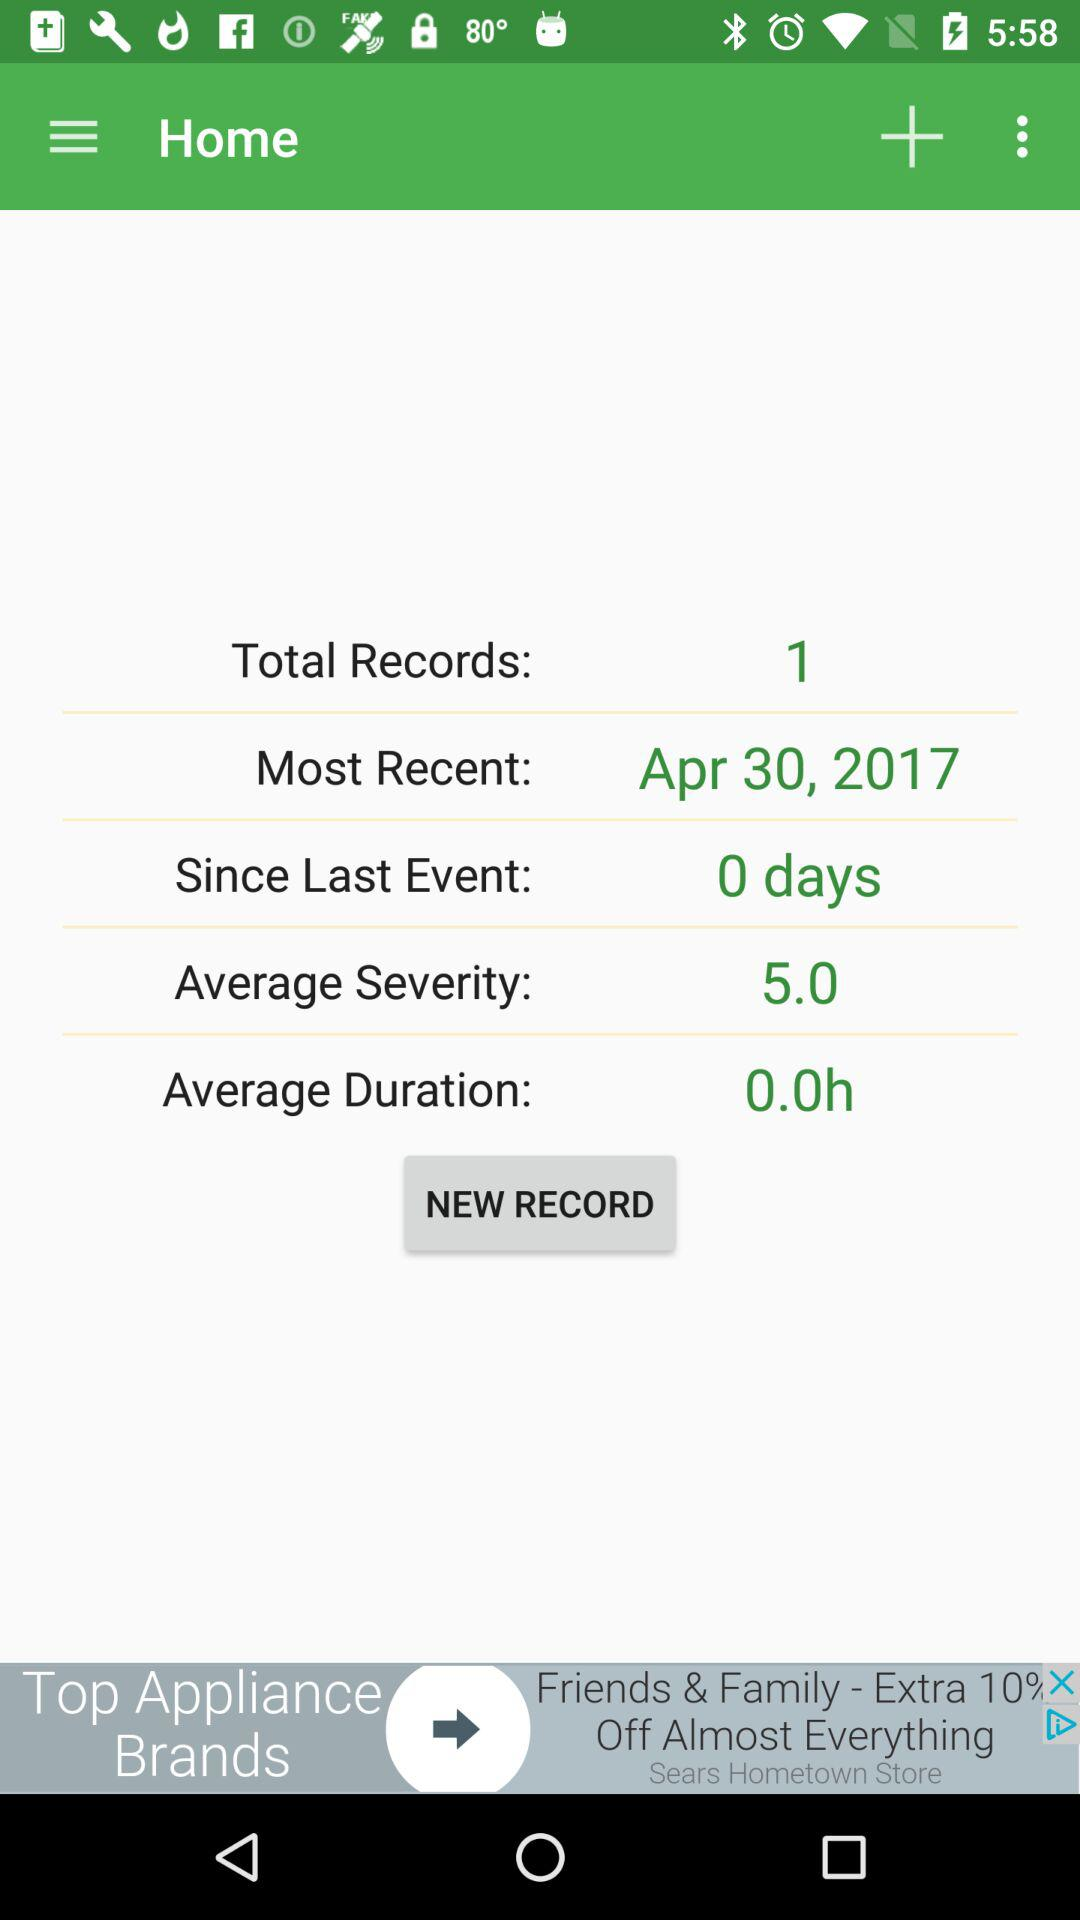How many days have passed since the last event? The number of days that have passed since the last event is 0. 